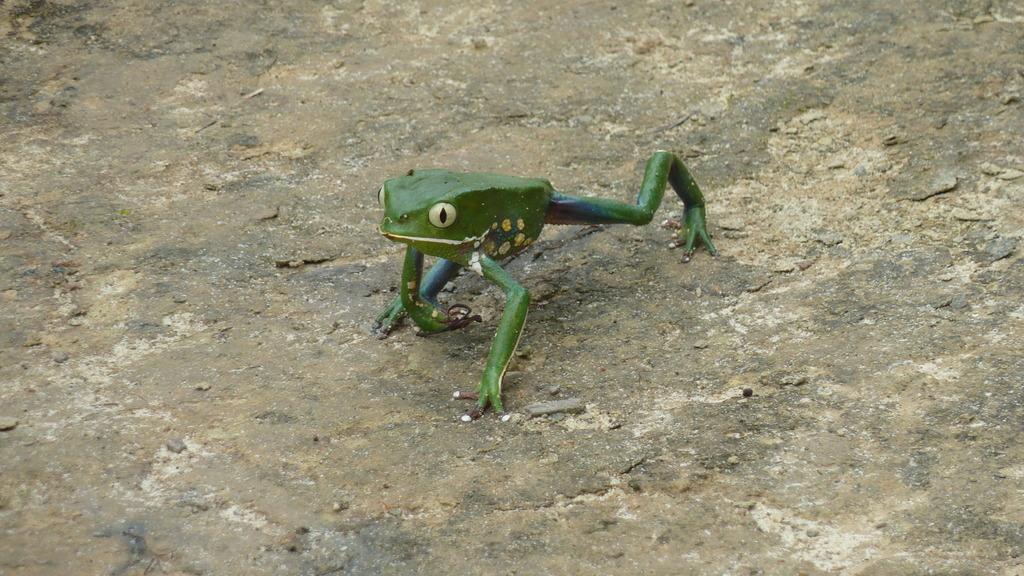Describe this image in one or two sentences. In the center of the image, we can see a frog on the ground. 